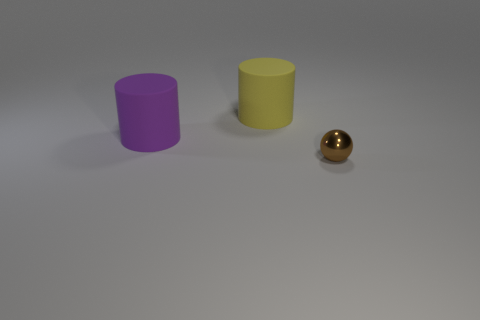Is there any other thing that has the same size as the sphere?
Make the answer very short. No. Is there anything else that is the same shape as the brown metal object?
Offer a terse response. No. Is there a yellow object of the same shape as the big purple object?
Keep it short and to the point. Yes. Is the shape of the matte thing that is to the left of the yellow cylinder the same as the large rubber object to the right of the purple thing?
Offer a very short reply. Yes. How many objects are either purple spheres or purple rubber things?
Ensure brevity in your answer.  1. What is the size of the other object that is the same shape as the purple object?
Give a very brief answer. Large. Is the number of big purple cylinders that are in front of the sphere greater than the number of purple shiny cubes?
Keep it short and to the point. No. Is the small thing made of the same material as the purple cylinder?
Give a very brief answer. No. What number of things are either tiny things that are on the right side of the purple matte cylinder or things on the left side of the shiny object?
Keep it short and to the point. 3. What color is the other matte object that is the same shape as the purple matte thing?
Make the answer very short. Yellow. 